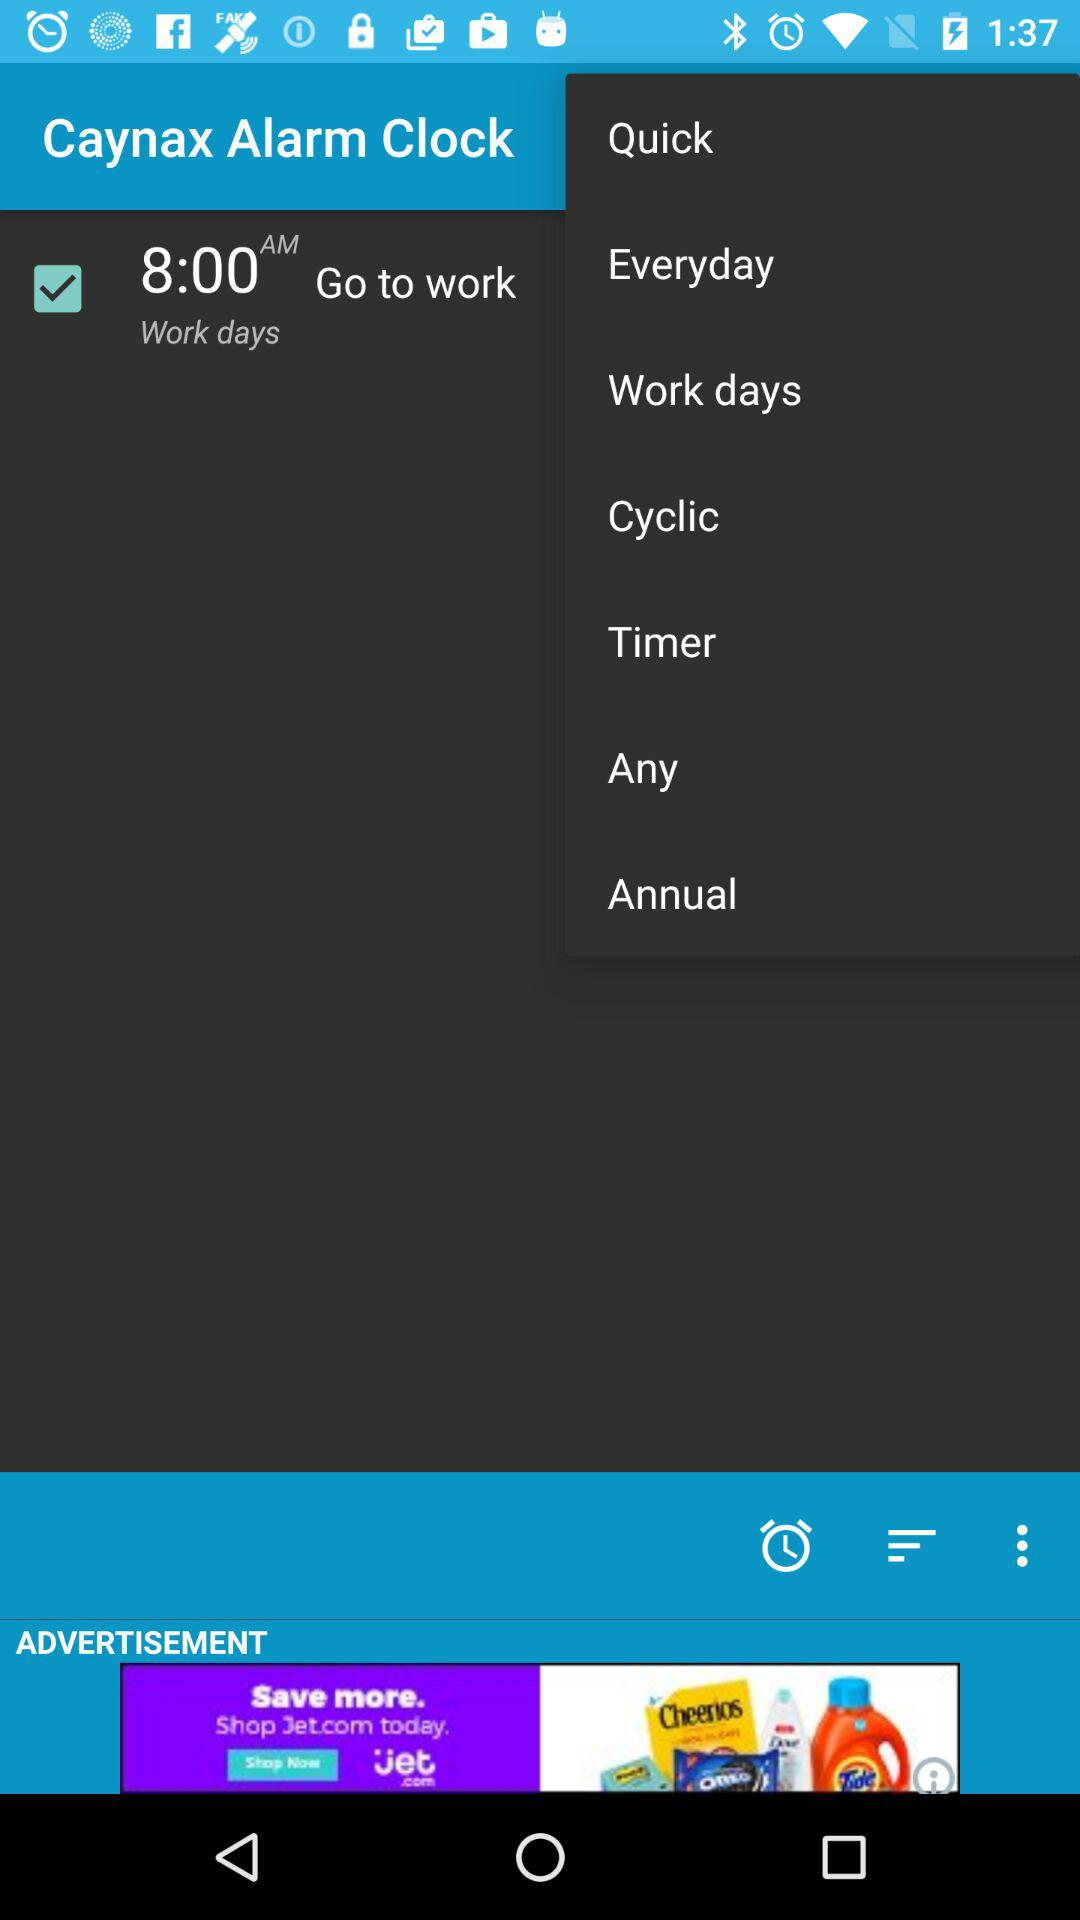For what time is the alarm set? The alarm is set for 8:00 AM. 